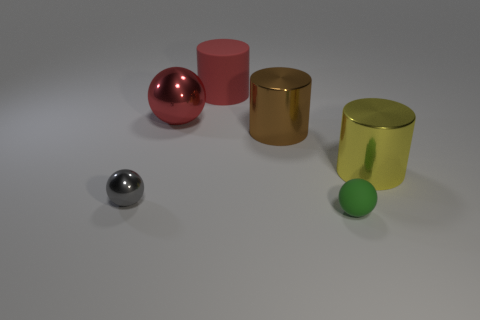Subtract all metallic balls. How many balls are left? 1 Add 3 large matte cylinders. How many objects exist? 9 Subtract 3 spheres. How many spheres are left? 0 Subtract all brown cylinders. How many cylinders are left? 2 Subtract 0 purple cylinders. How many objects are left? 6 Subtract all gray cylinders. Subtract all red cubes. How many cylinders are left? 3 Subtract all purple metallic cylinders. Subtract all cylinders. How many objects are left? 3 Add 3 large balls. How many large balls are left? 4 Add 1 yellow objects. How many yellow objects exist? 2 